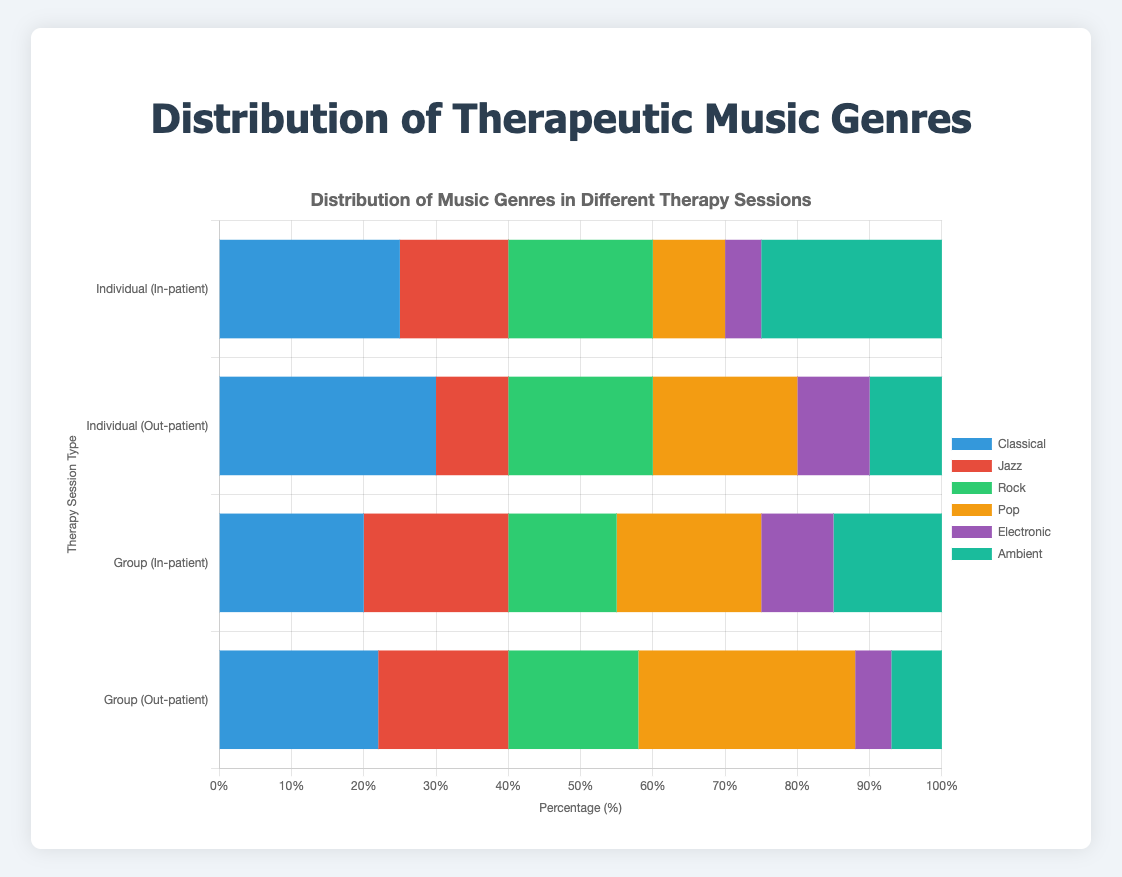What's the most preferred music genre in individual sessions for in-patient therapy? To find the most preferred genre, look at the bars for "Individual (In-patient)" and identify the longest bar. The genre with the longest bar for in-patient individual sessions is Classical and Ambient.
Answer: Classical, Ambient Which music genre is equally preferred in both individual sessions for in-patients and group sessions for out-patients? Look at the bars for both "Individual (In-patient)" and "Group (Out-patient)" and find the genres where the bar lengths are the same. In this case, the Rock genre has equal counts of 20 in both session types.
Answer: Rock What music genre has the least preference in individual sessions for out-patient therapy? Check the "Individual (Out-patient)" bars and find the genre with the shortest bar. The smallest bar is for Ambient at 10.
Answer: Ambient Is there a music genre that has the same preference across all therapy session types? Compare the bars for each music genre across all four therapy session types to see if any have the same length. There is no genre with the same preference across all therapy types.
Answer: No What is the sum of Classical and Jazz preferences in group sessions for in-patients? Add the values of Classical and Jazz preferences for "Group (In-patient)": Classical (20) + Jazz (20) = 40.
Answer: 40 Which session type shows the highest preference for Pop music? Compare the bars for Pop music across all session types and identify the longest bar. "Group (Out-patient)" has the longest Pop bar at 30.
Answer: Group (Out-patient) What is the difference in preference for Ambient music between individual sessions for in-patients and group sessions for in-patients? Subtract the value of Ambient for individual in-patients (25) from Ambient for group in-patients (15): 25 - 15 = 10.
Answer: 10 Which genre has the widest range of preferences among all therapy session types? Find the difference between the maximum and minimum values for each genre. Classical ranges from 20 to 30, Jazz from 10 to 20, Rock from 15 to 20, Pop from 10 to 30, Electronic from 5 to 10, and Ambient from 7 to 25. The widest range is for Pop (30 - 10 = 20).
Answer: Pop How many music genres have an equal preference in individual and group sessions for out-patient therapy? Compare the values of each genre between "Individual (Out-patient)" and "Group (Out-patient)" and count genres with equal values. Only Rock has equal values (20).
Answer: 1 What is the average preference for Electronic music across all therapy session types? Add the values for Electronic music in each session type and divide by the number of session types: (5 + 10 + 10 + 5) / 4 = 7.5.
Answer: 7.5 